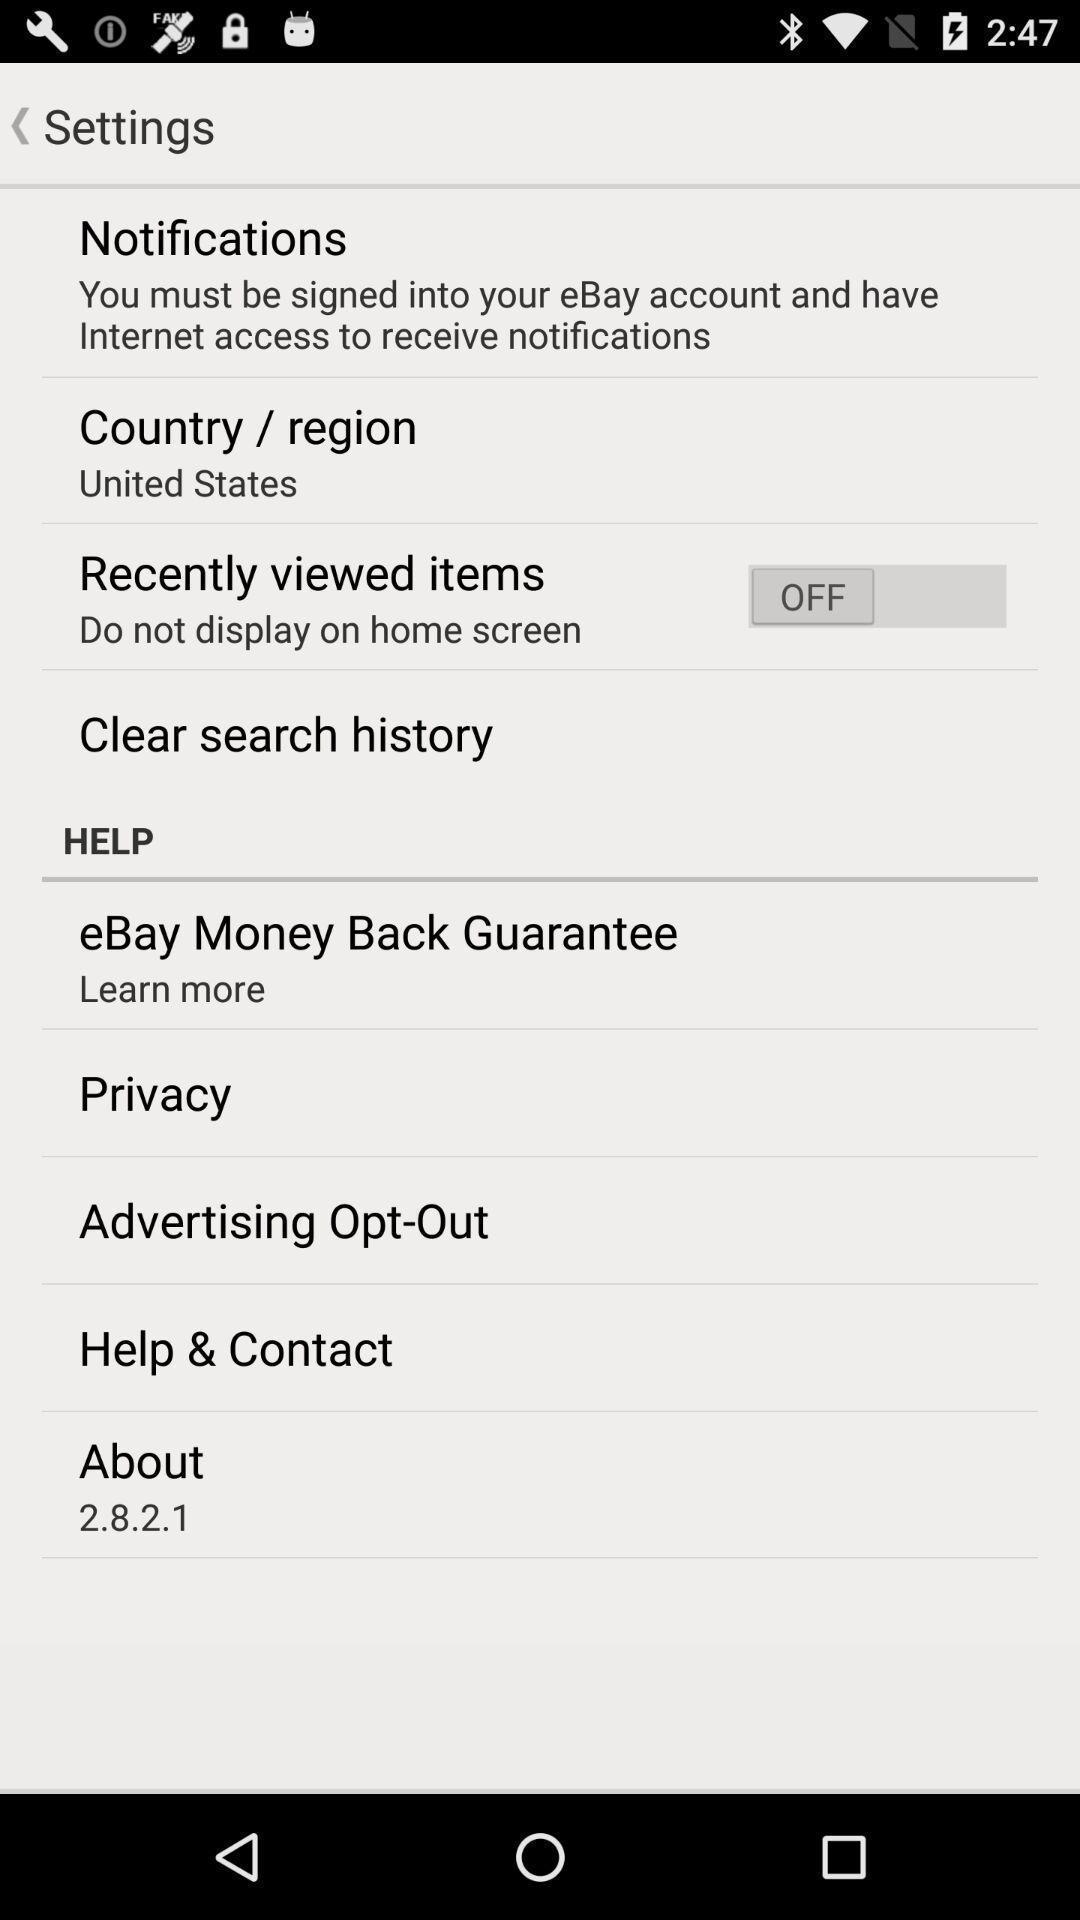Summarize the information in this screenshot. Setting options in the mobile phone. 